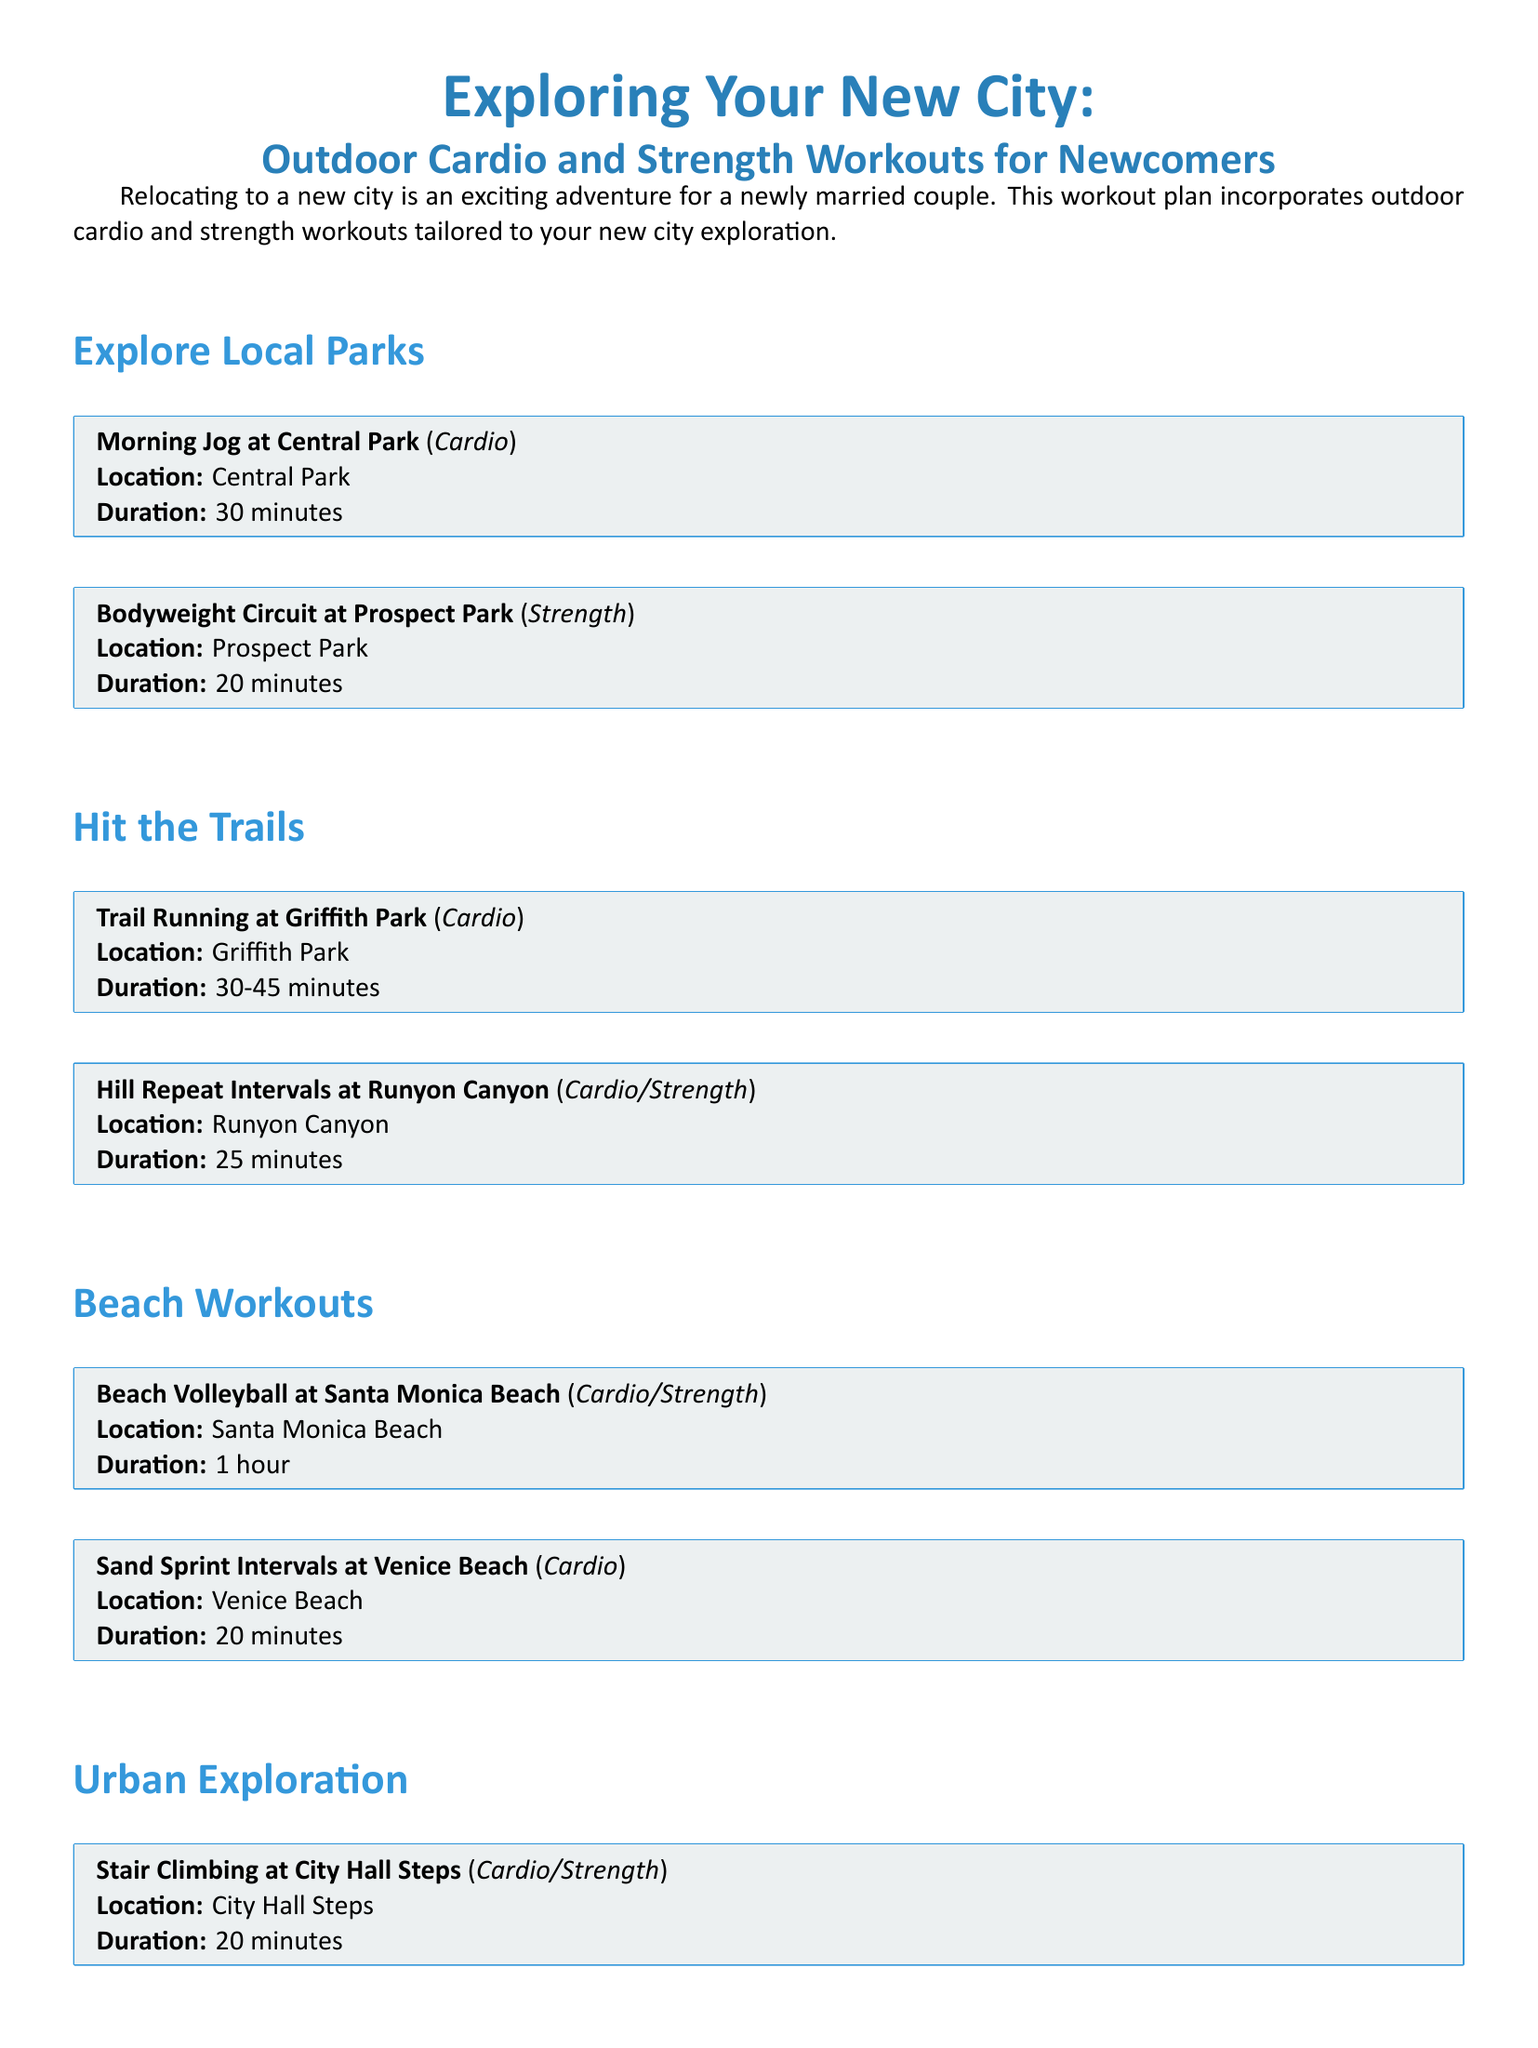What is the title of the document? The title of the document is mentioned at the beginning and appears as "Exploring Your New City: Outdoor Cardio and Strength Workouts for Newcomers."
Answer: Exploring Your New City: Outdoor Cardio and Strength Workouts for Newcomers How long is the Morning Jog at Central Park? The duration for the Morning Jog at Central Park is specified in the workout box.
Answer: 30 minutes What type of workout is the Bodyweight Circuit at Prospect Park? The workout type for the Bodyweight Circuit at Prospect Park is indicated in the workout box.
Answer: Strength Where can I do Sand Sprint Intervals? The location for Sand Sprint Intervals is mentioned in the workout box for that activity.
Answer: Venice Beach What activity lasts for 1 hour? The document lists an activity that has a specific duration of 1 hour in the workout box.
Answer: Beach Volleyball at Santa Monica Beach Which workout includes both cardio and strength elements? The document specifies a workout that combines both cardio and strength elements in its description.
Answer: Hill Repeat Intervals at Runyon Canyon What is the duration of the Urban Bootcamp at Millennium Park? The duration for the Urban Bootcamp at Millennium Park is indicated in the workout box.
Answer: 30 minutes How many parks are mentioned for outdoor workouts? The document lists several parks for outdoor workouts, which can be counted to answer this question.
Answer: Four 